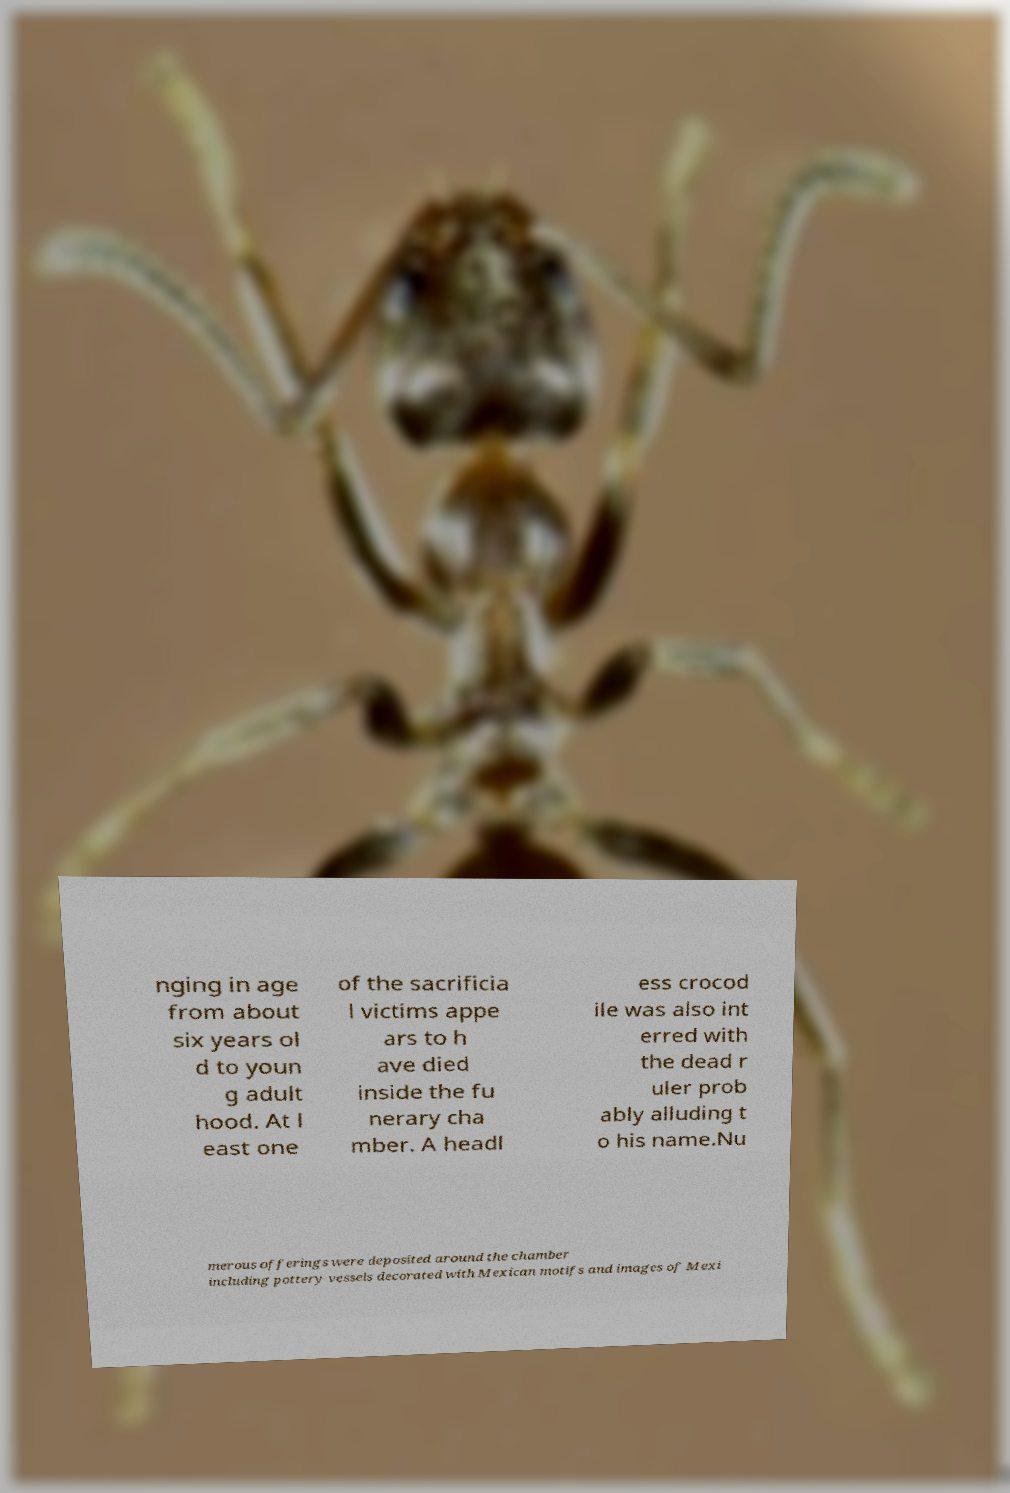There's text embedded in this image that I need extracted. Can you transcribe it verbatim? nging in age from about six years ol d to youn g adult hood. At l east one of the sacrificia l victims appe ars to h ave died inside the fu nerary cha mber. A headl ess crocod ile was also int erred with the dead r uler prob ably alluding t o his name.Nu merous offerings were deposited around the chamber including pottery vessels decorated with Mexican motifs and images of Mexi 